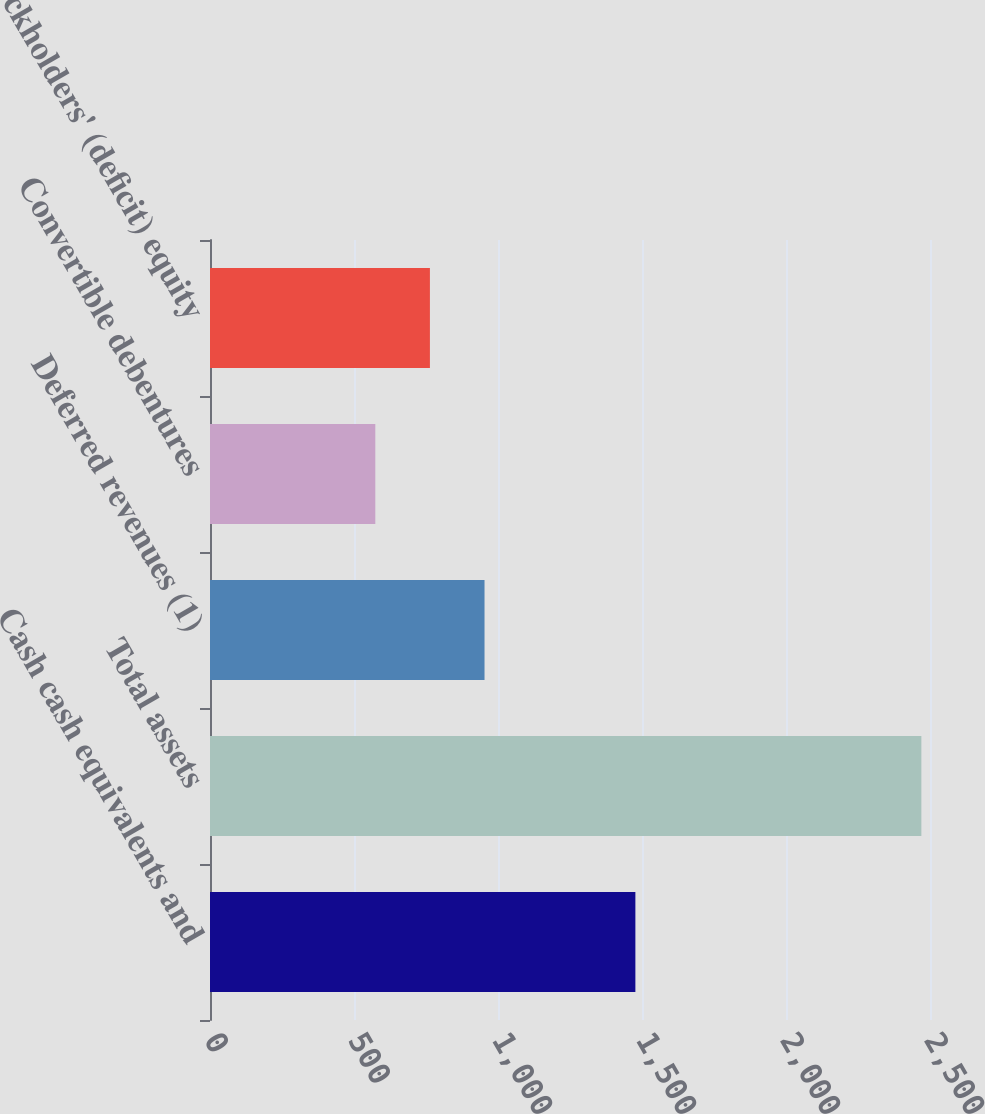<chart> <loc_0><loc_0><loc_500><loc_500><bar_chart><fcel>Cash cash equivalents and<fcel>Total assets<fcel>Deferred revenues (1)<fcel>Convertible debentures<fcel>Stockholders' (deficit) equity<nl><fcel>1477<fcel>2470<fcel>953.2<fcel>574<fcel>763.6<nl></chart> 